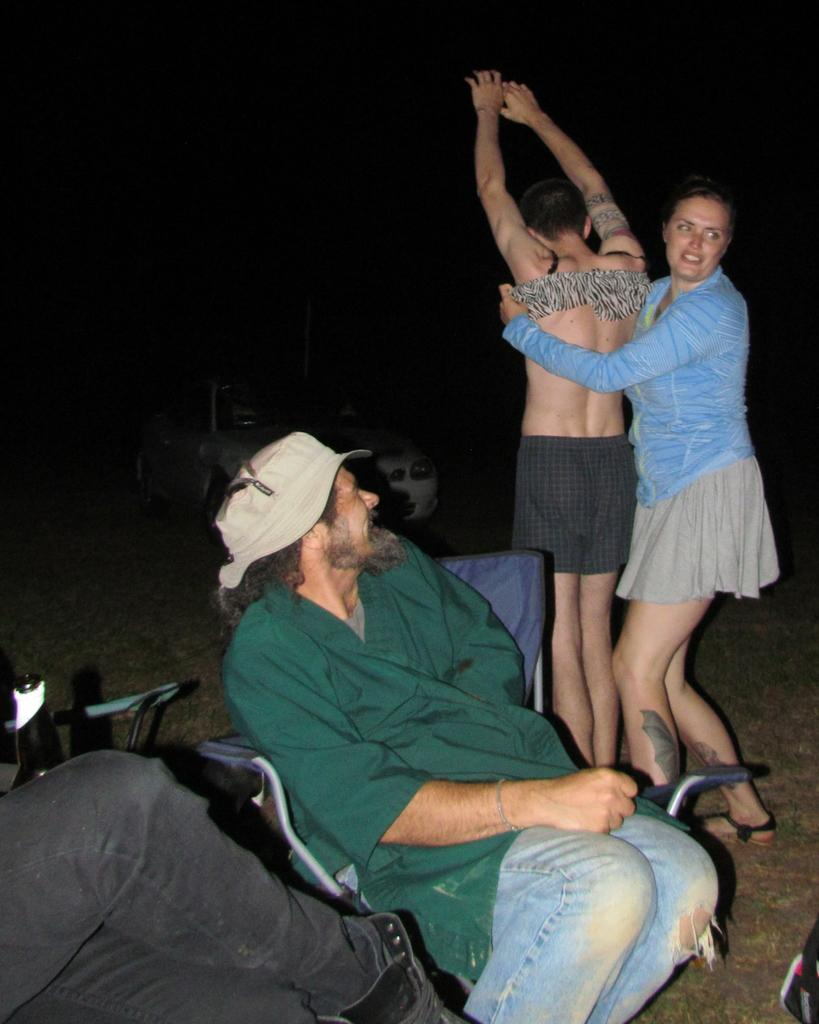How many people are present in the image? There are two people standing in the image. What are the people in the image doing? There are people sitting in the image as well. What object can be seen in the image that is typically used for holding liquids? There is a bottle in the image. What can be seen in the background of the image? There is a car in the background of the image. What type of net is being used to catch the fish in the image? There is no net or fish present in the image; it features people standing and sitting with a bottle and a car in the background. 